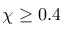Convert formula to latex. <formula><loc_0><loc_0><loc_500><loc_500>\chi \geq 0 . 4</formula> 